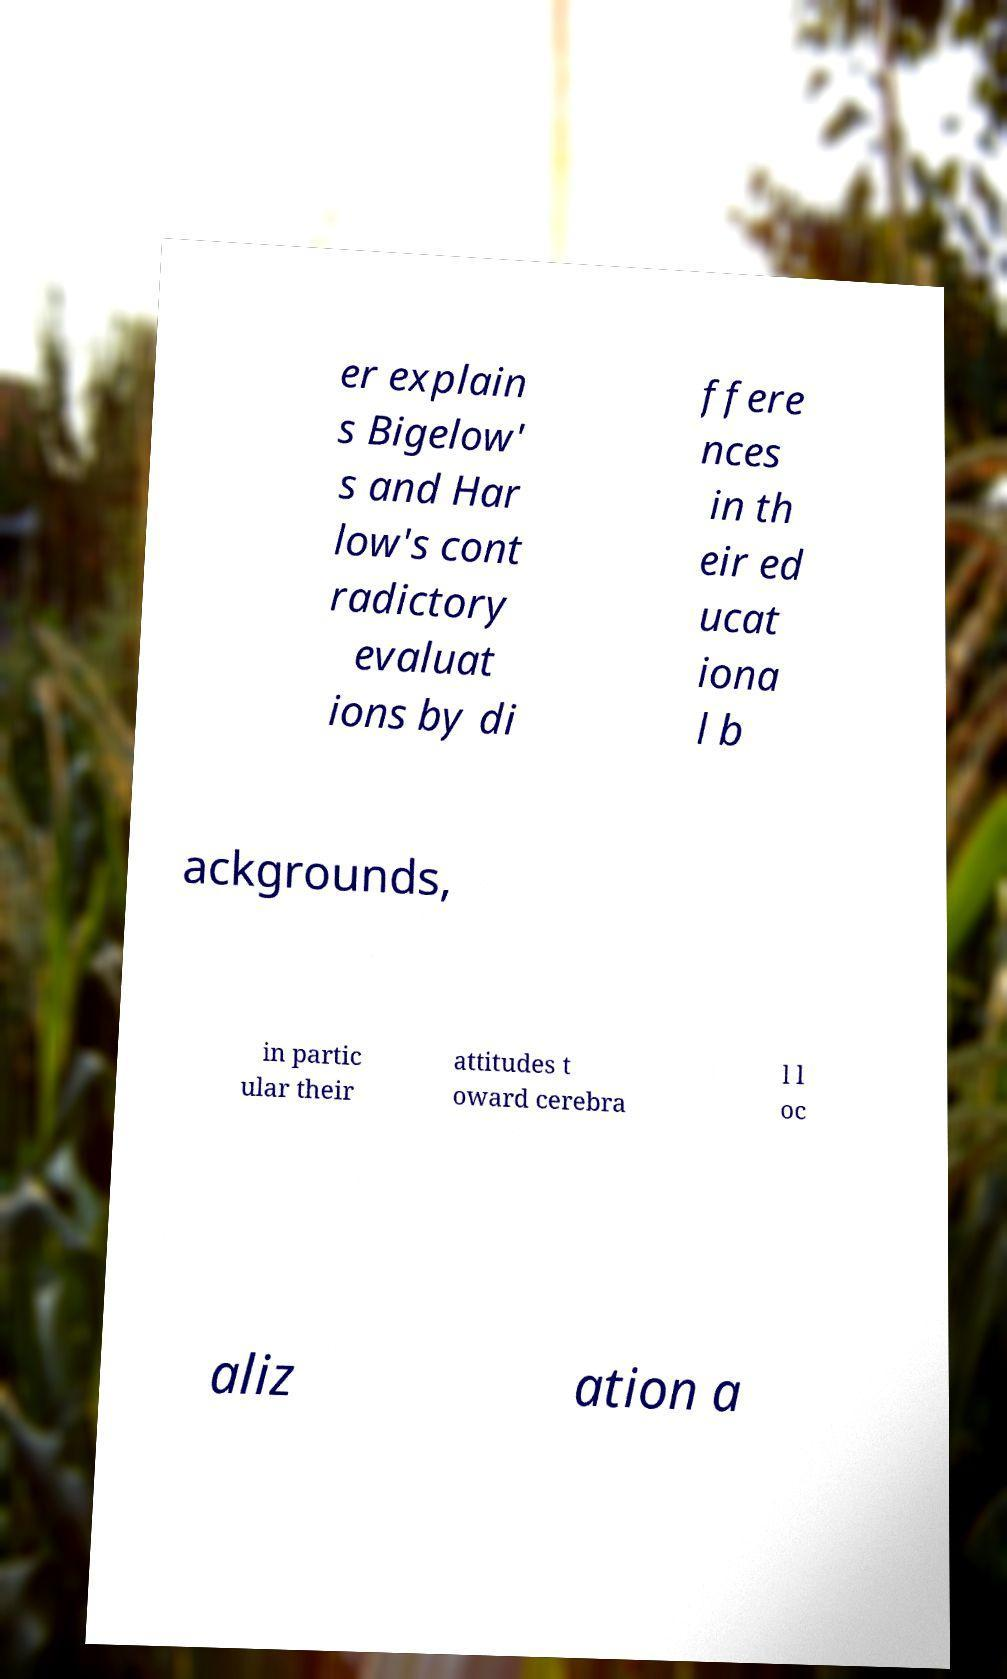What messages or text are displayed in this image? I need them in a readable, typed format. er explain s Bigelow' s and Har low's cont radictory evaluat ions by di ffere nces in th eir ed ucat iona l b ackgrounds, in partic ular their attitudes t oward cerebra l l oc aliz ation a 